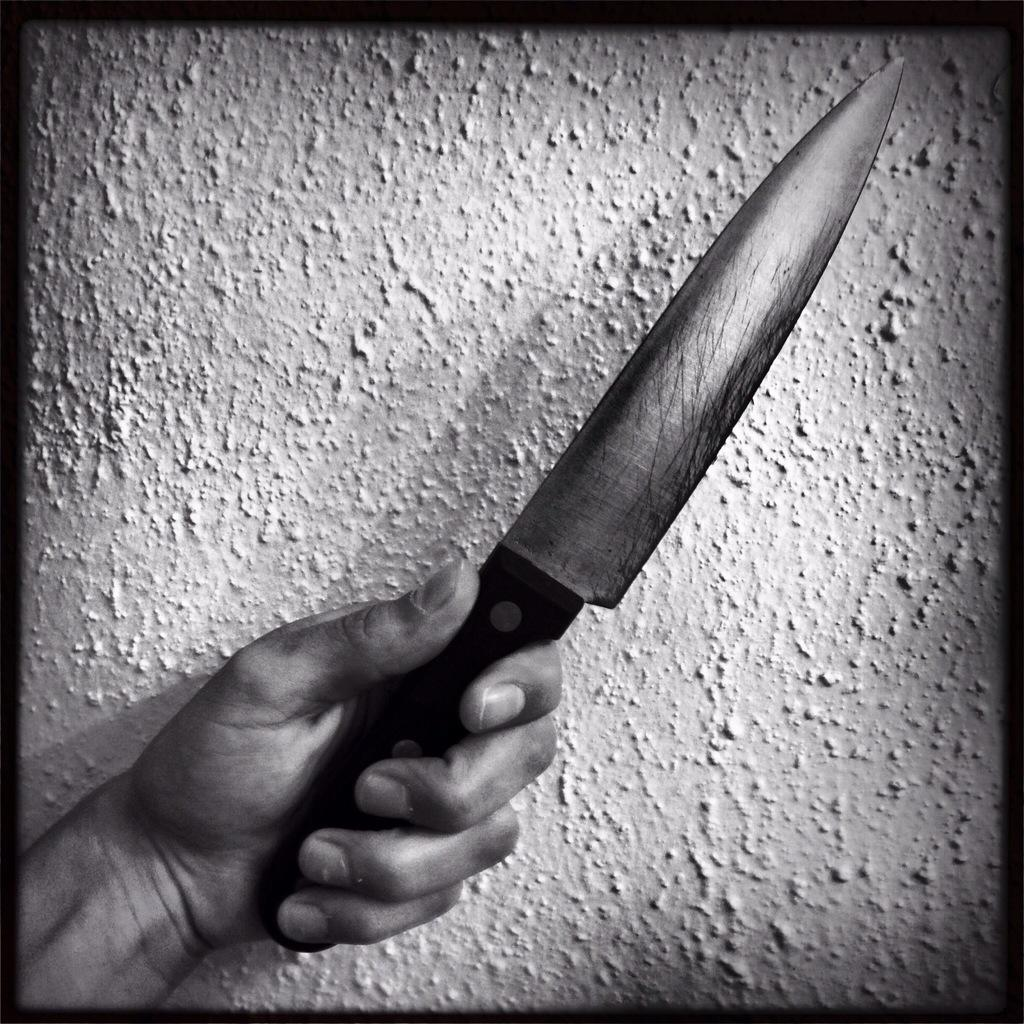What is the color scheme of the image? The image is black and white. Has the image been altered in any way? Yes, the image is edited. What is the person in the image doing? There is a person's hand holding a knife in the image. What can be seen in the background of the image? There is a wall in the background of the image. What type of bread is being balanced on the knife in the image? There is no bread present in the image, and the knife is not being used to balance anything. How does the person in the image cough while holding the knife? There is no indication in the image that the person is coughing or holding the knife in a way that would suggest coughing. 